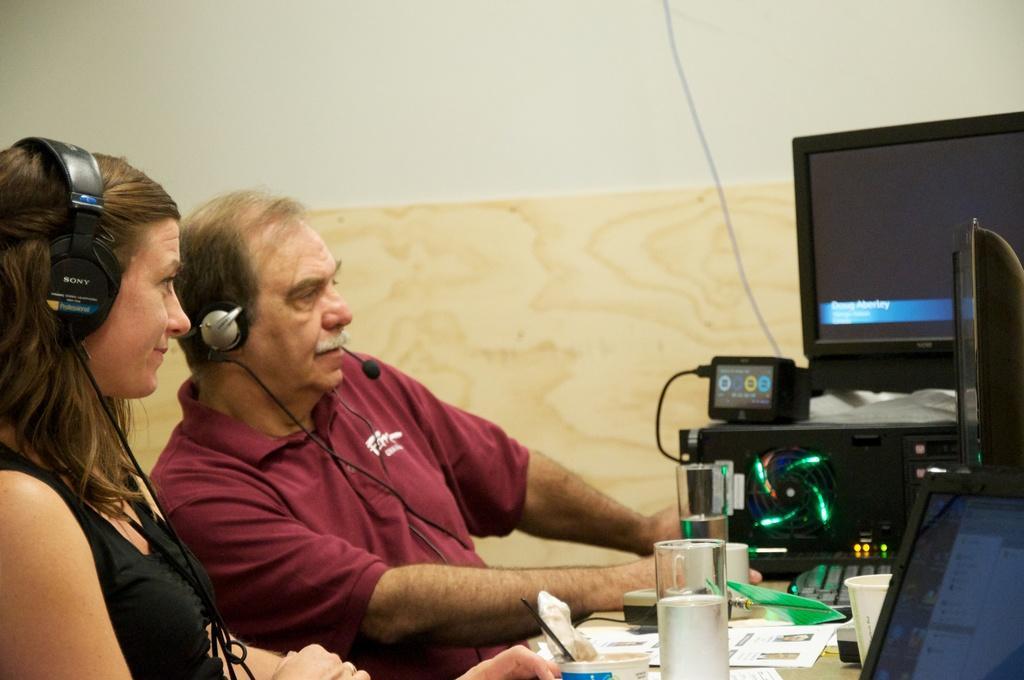In one or two sentences, can you explain what this image depicts? To the left side of the image there are two persons. There is a table in front of them on which there are many objects. In the background of the image there is a wall. 